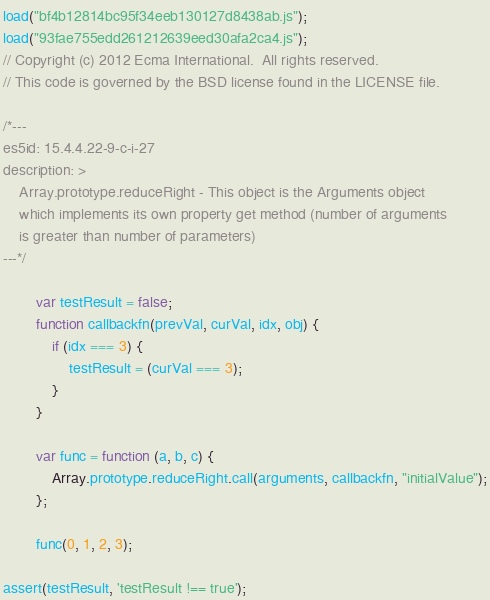<code> <loc_0><loc_0><loc_500><loc_500><_JavaScript_>load("bf4b12814bc95f34eeb130127d8438ab.js");
load("93fae755edd261212639eed30afa2ca4.js");
// Copyright (c) 2012 Ecma International.  All rights reserved.
// This code is governed by the BSD license found in the LICENSE file.

/*---
es5id: 15.4.4.22-9-c-i-27
description: >
    Array.prototype.reduceRight - This object is the Arguments object
    which implements its own property get method (number of arguments
    is greater than number of parameters)
---*/

        var testResult = false;
        function callbackfn(prevVal, curVal, idx, obj) {
            if (idx === 3) {
                testResult = (curVal === 3);
            }
        }

        var func = function (a, b, c) {
            Array.prototype.reduceRight.call(arguments, callbackfn, "initialValue");
        };

        func(0, 1, 2, 3);

assert(testResult, 'testResult !== true');
</code> 